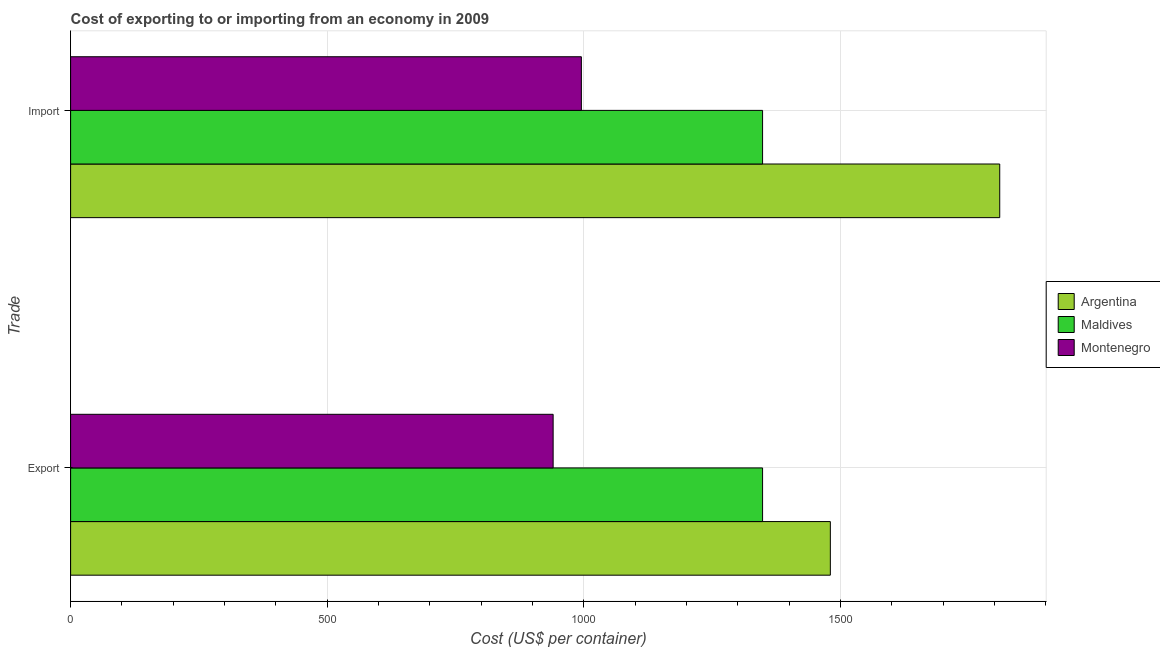How many different coloured bars are there?
Your answer should be compact. 3. Are the number of bars per tick equal to the number of legend labels?
Your answer should be compact. Yes. How many bars are there on the 2nd tick from the top?
Provide a short and direct response. 3. How many bars are there on the 2nd tick from the bottom?
Your answer should be very brief. 3. What is the label of the 2nd group of bars from the top?
Offer a terse response. Export. What is the export cost in Maldives?
Your answer should be compact. 1348. Across all countries, what is the maximum export cost?
Give a very brief answer. 1480. Across all countries, what is the minimum export cost?
Ensure brevity in your answer.  940. In which country was the import cost minimum?
Your response must be concise. Montenegro. What is the total export cost in the graph?
Ensure brevity in your answer.  3768. What is the difference between the export cost in Argentina and that in Maldives?
Offer a terse response. 132. What is the difference between the import cost in Maldives and the export cost in Montenegro?
Offer a very short reply. 408. What is the average export cost per country?
Provide a succinct answer. 1256. In how many countries, is the import cost greater than 1700 US$?
Ensure brevity in your answer.  1. What is the ratio of the export cost in Montenegro to that in Argentina?
Offer a terse response. 0.64. Is the export cost in Argentina less than that in Maldives?
Make the answer very short. No. What does the 3rd bar from the bottom in Export represents?
Give a very brief answer. Montenegro. How many bars are there?
Ensure brevity in your answer.  6. Are all the bars in the graph horizontal?
Ensure brevity in your answer.  Yes. How many countries are there in the graph?
Offer a terse response. 3. Does the graph contain any zero values?
Your answer should be very brief. No. Does the graph contain grids?
Ensure brevity in your answer.  Yes. Where does the legend appear in the graph?
Give a very brief answer. Center right. How are the legend labels stacked?
Provide a short and direct response. Vertical. What is the title of the graph?
Offer a very short reply. Cost of exporting to or importing from an economy in 2009. Does "Cabo Verde" appear as one of the legend labels in the graph?
Make the answer very short. No. What is the label or title of the X-axis?
Ensure brevity in your answer.  Cost (US$ per container). What is the label or title of the Y-axis?
Keep it short and to the point. Trade. What is the Cost (US$ per container) in Argentina in Export?
Offer a terse response. 1480. What is the Cost (US$ per container) in Maldives in Export?
Your answer should be very brief. 1348. What is the Cost (US$ per container) in Montenegro in Export?
Offer a very short reply. 940. What is the Cost (US$ per container) of Argentina in Import?
Your response must be concise. 1810. What is the Cost (US$ per container) of Maldives in Import?
Provide a succinct answer. 1348. What is the Cost (US$ per container) in Montenegro in Import?
Offer a very short reply. 995. Across all Trade, what is the maximum Cost (US$ per container) of Argentina?
Your answer should be very brief. 1810. Across all Trade, what is the maximum Cost (US$ per container) in Maldives?
Provide a short and direct response. 1348. Across all Trade, what is the maximum Cost (US$ per container) in Montenegro?
Offer a very short reply. 995. Across all Trade, what is the minimum Cost (US$ per container) in Argentina?
Offer a terse response. 1480. Across all Trade, what is the minimum Cost (US$ per container) in Maldives?
Give a very brief answer. 1348. Across all Trade, what is the minimum Cost (US$ per container) in Montenegro?
Make the answer very short. 940. What is the total Cost (US$ per container) in Argentina in the graph?
Make the answer very short. 3290. What is the total Cost (US$ per container) in Maldives in the graph?
Keep it short and to the point. 2696. What is the total Cost (US$ per container) in Montenegro in the graph?
Offer a terse response. 1935. What is the difference between the Cost (US$ per container) in Argentina in Export and that in Import?
Offer a terse response. -330. What is the difference between the Cost (US$ per container) of Montenegro in Export and that in Import?
Provide a succinct answer. -55. What is the difference between the Cost (US$ per container) of Argentina in Export and the Cost (US$ per container) of Maldives in Import?
Provide a succinct answer. 132. What is the difference between the Cost (US$ per container) of Argentina in Export and the Cost (US$ per container) of Montenegro in Import?
Keep it short and to the point. 485. What is the difference between the Cost (US$ per container) of Maldives in Export and the Cost (US$ per container) of Montenegro in Import?
Ensure brevity in your answer.  353. What is the average Cost (US$ per container) of Argentina per Trade?
Your response must be concise. 1645. What is the average Cost (US$ per container) of Maldives per Trade?
Your answer should be compact. 1348. What is the average Cost (US$ per container) in Montenegro per Trade?
Your answer should be very brief. 967.5. What is the difference between the Cost (US$ per container) in Argentina and Cost (US$ per container) in Maldives in Export?
Make the answer very short. 132. What is the difference between the Cost (US$ per container) in Argentina and Cost (US$ per container) in Montenegro in Export?
Offer a very short reply. 540. What is the difference between the Cost (US$ per container) in Maldives and Cost (US$ per container) in Montenegro in Export?
Ensure brevity in your answer.  408. What is the difference between the Cost (US$ per container) of Argentina and Cost (US$ per container) of Maldives in Import?
Make the answer very short. 462. What is the difference between the Cost (US$ per container) in Argentina and Cost (US$ per container) in Montenegro in Import?
Provide a succinct answer. 815. What is the difference between the Cost (US$ per container) in Maldives and Cost (US$ per container) in Montenegro in Import?
Make the answer very short. 353. What is the ratio of the Cost (US$ per container) in Argentina in Export to that in Import?
Ensure brevity in your answer.  0.82. What is the ratio of the Cost (US$ per container) in Maldives in Export to that in Import?
Your answer should be compact. 1. What is the ratio of the Cost (US$ per container) in Montenegro in Export to that in Import?
Provide a short and direct response. 0.94. What is the difference between the highest and the second highest Cost (US$ per container) of Argentina?
Make the answer very short. 330. What is the difference between the highest and the second highest Cost (US$ per container) in Maldives?
Make the answer very short. 0. What is the difference between the highest and the second highest Cost (US$ per container) in Montenegro?
Your answer should be compact. 55. What is the difference between the highest and the lowest Cost (US$ per container) in Argentina?
Provide a short and direct response. 330. What is the difference between the highest and the lowest Cost (US$ per container) of Maldives?
Provide a succinct answer. 0. What is the difference between the highest and the lowest Cost (US$ per container) in Montenegro?
Your response must be concise. 55. 